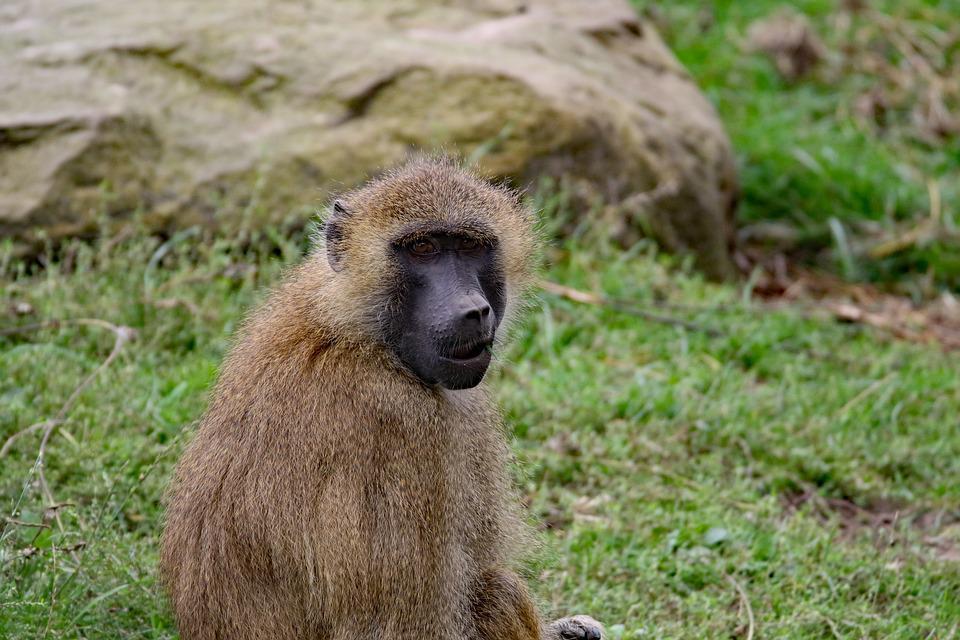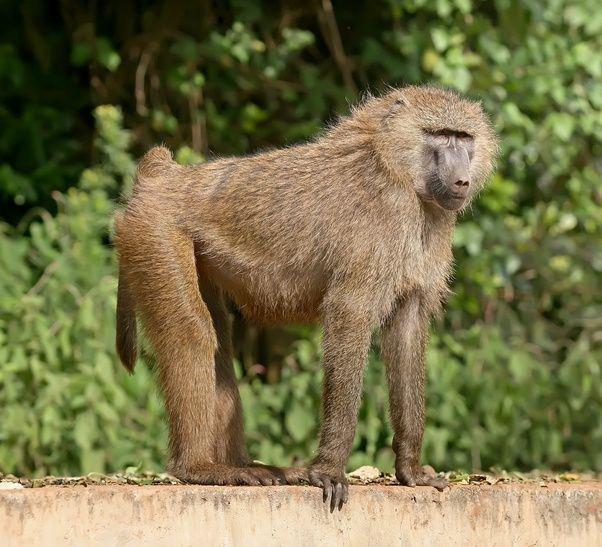The first image is the image on the left, the second image is the image on the right. Given the left and right images, does the statement "Each image contains a single baboon, and all baboons are in standing positions." hold true? Answer yes or no. No. 